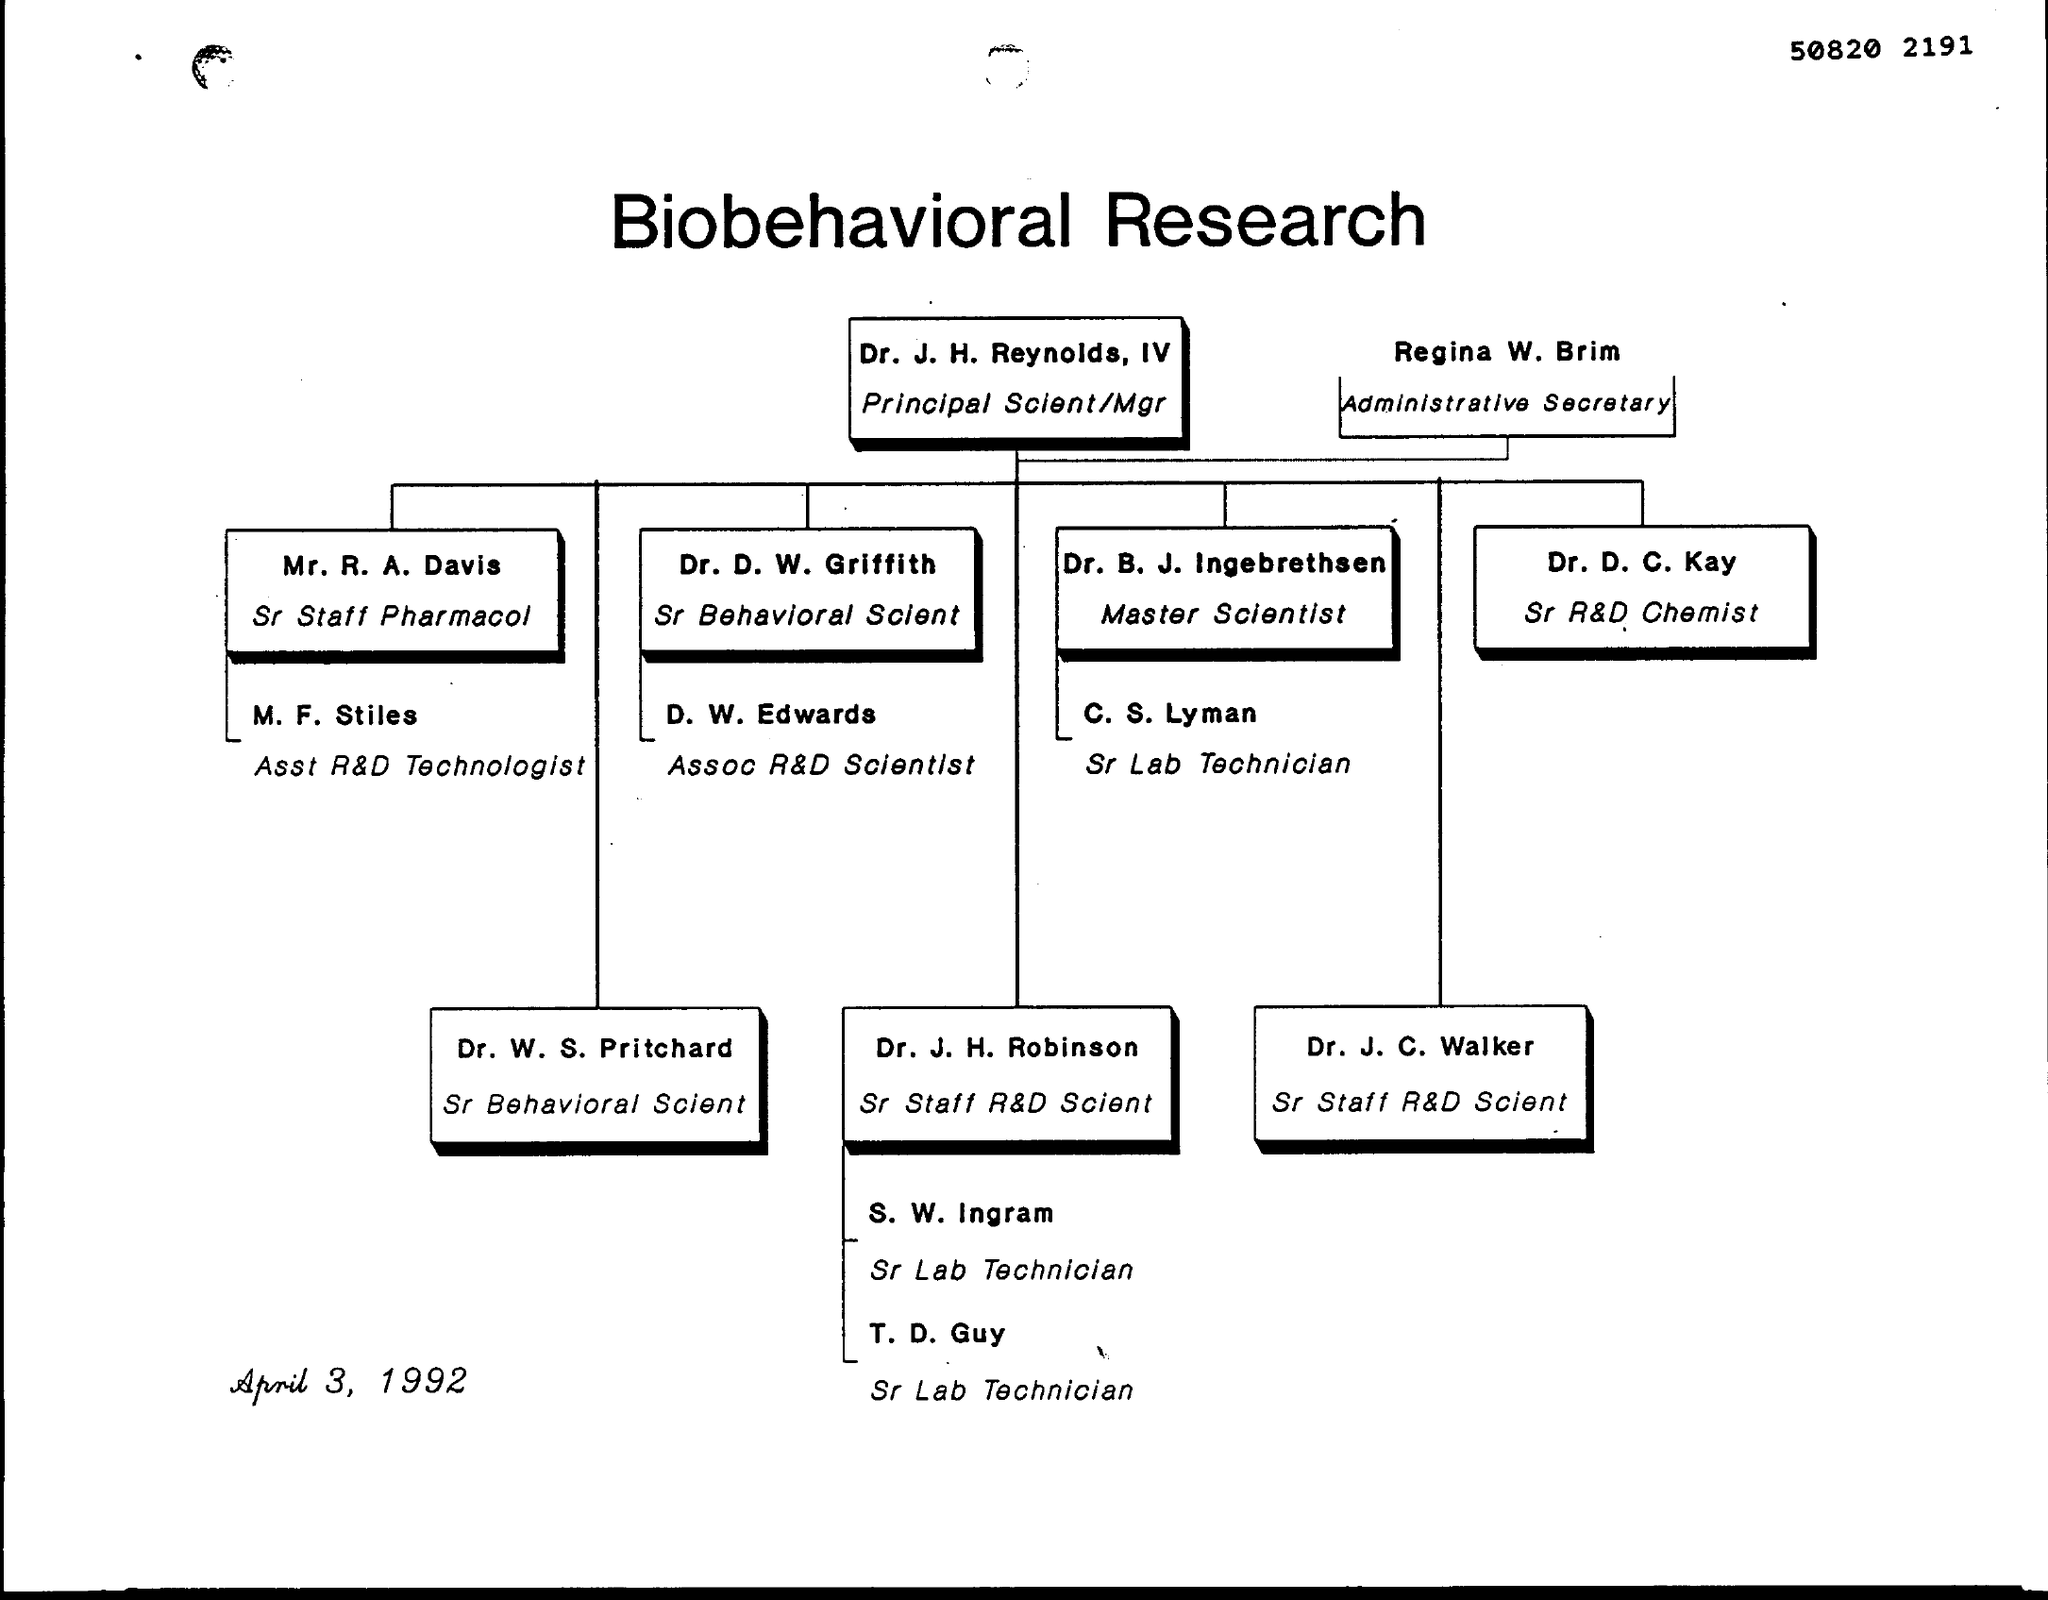Outline some significant characteristics in this image. Dr. J.H. Reynolds, IV was employed as a Principal Scientist/Manager. The Sr. Lab Technician under the Master Scientist is C. S. Lyman. Regina W. Brim was the administrative secretary. 